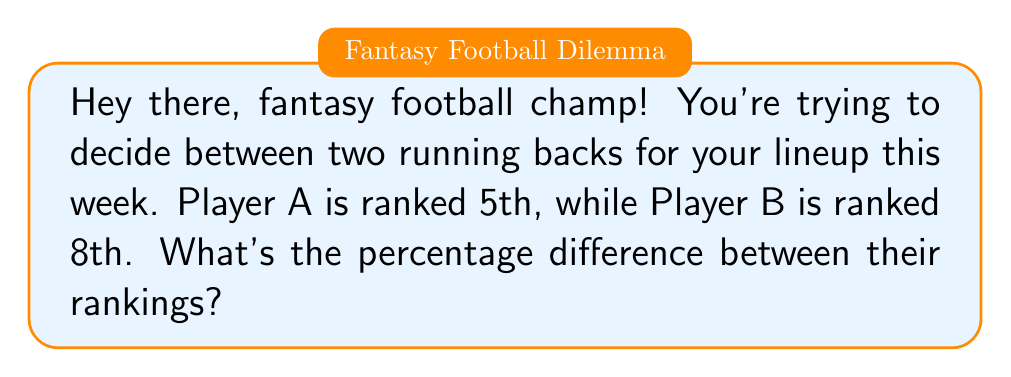Can you solve this math problem? Alright, little buddy! Let's break this down step-by-step:

1) First, we need to understand what percentage difference means. It's the difference between two values, expressed as a percentage of their average.

2) The formula for percentage difference is:

   $$ \text{Percentage Difference} = \frac{|\text{Value 1} - \text{Value 2}|}{\frac{\text{Value 1} + \text{Value 2}}{2}} \times 100\% $$

   Where $|\text{Value 1} - \text{Value 2}|$ means the absolute difference between the two values.

3) In our case:
   Value 1 (Player A's ranking) = 5
   Value 2 (Player B's ranking) = 8

4) Let's plug these into our formula:

   $$ \text{Percentage Difference} = \frac{|5 - 8|}{\frac{5 + 8}{2}} \times 100\% $$

5) First, let's calculate the numerator:
   $|5 - 8| = |-3| = 3$

6) Now, the denominator:
   $\frac{5 + 8}{2} = \frac{13}{2} = 6.5$

7) Putting it all together:

   $$ \text{Percentage Difference} = \frac{3}{6.5} \times 100\% = 0.4615... \times 100\% = 46.15\% $$

8) Rounding to the nearest whole percentage, we get 46%.

So, the percentage difference between Player A's ranking (5th) and Player B's ranking (8th) is about 46%.
Answer: 46% 